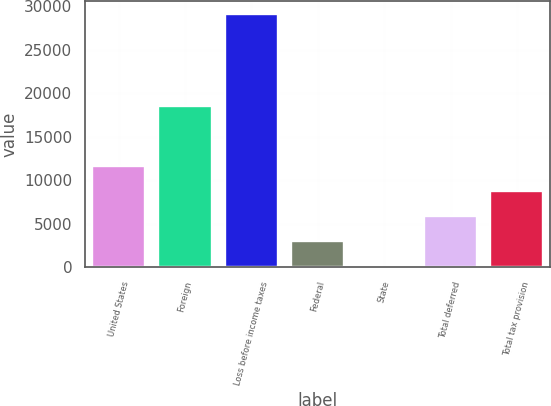Convert chart. <chart><loc_0><loc_0><loc_500><loc_500><bar_chart><fcel>United States<fcel>Foreign<fcel>Loss before income taxes<fcel>Federal<fcel>State<fcel>Total deferred<fcel>Total tax provision<nl><fcel>11664.8<fcel>18494<fcel>29093<fcel>2950.7<fcel>46<fcel>5855.4<fcel>8760.1<nl></chart> 